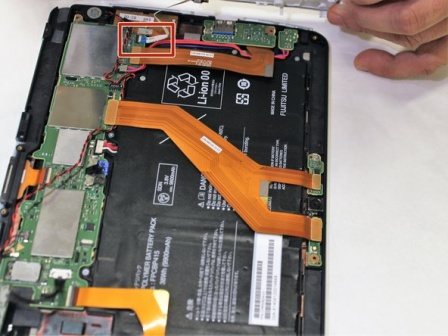What's happening in the scene? The image shows a tablet that has been dismantled to expose its internal components. A hand, using a white stylus, is either repairing or examining the tablet's intricate hardware. We see a variety of components like a large black battery, several orange and red cables connecting different parts, and a circuit board. This peek into the tablet’s interior highlights the complexity and precision required in modern electronic design and repair. 